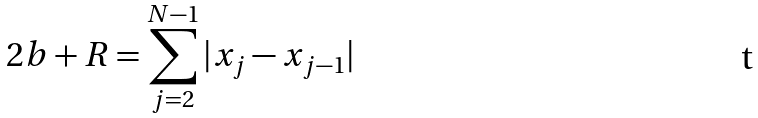<formula> <loc_0><loc_0><loc_500><loc_500>2 b + R = \sum _ { j = 2 } ^ { N - 1 } | { x } _ { j } - { x } _ { j - 1 } |</formula> 